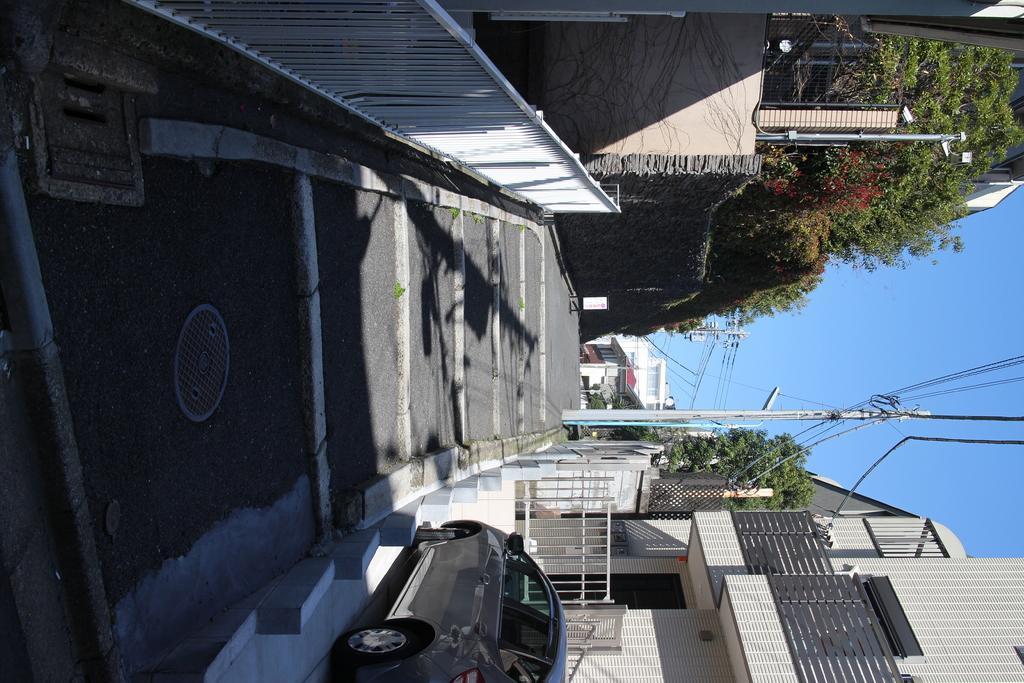Please provide a concise description of this image. This image consists of a road. To the right and left there are buildings. At the bottom, there is a car. And there are trees along with pole and wires. 